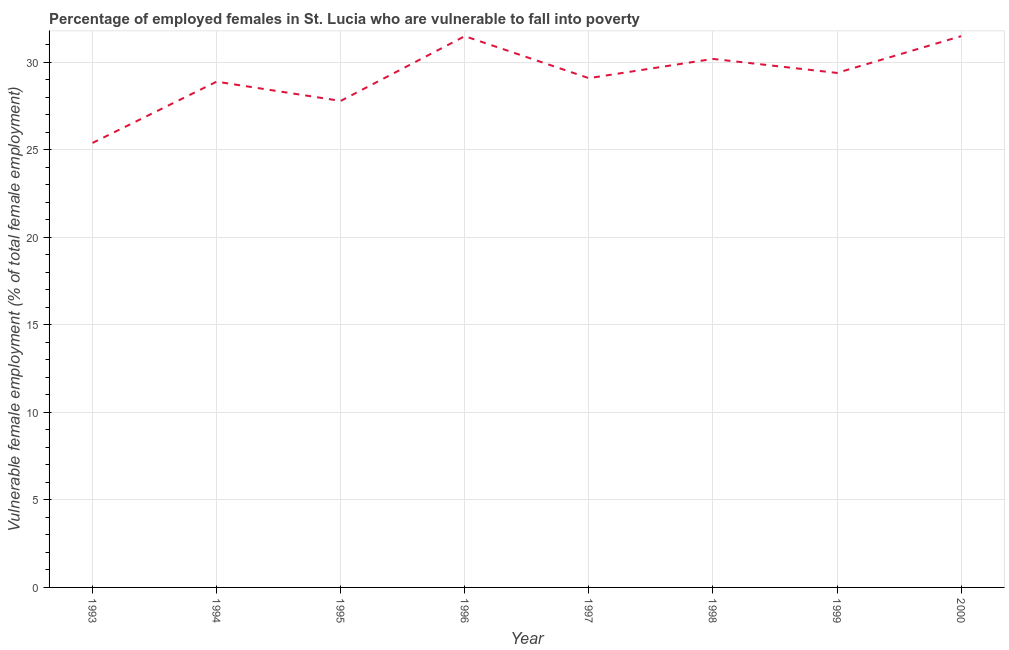What is the percentage of employed females who are vulnerable to fall into poverty in 1998?
Give a very brief answer. 30.2. Across all years, what is the maximum percentage of employed females who are vulnerable to fall into poverty?
Make the answer very short. 31.5. Across all years, what is the minimum percentage of employed females who are vulnerable to fall into poverty?
Keep it short and to the point. 25.4. In which year was the percentage of employed females who are vulnerable to fall into poverty maximum?
Ensure brevity in your answer.  1996. What is the sum of the percentage of employed females who are vulnerable to fall into poverty?
Your response must be concise. 233.8. What is the average percentage of employed females who are vulnerable to fall into poverty per year?
Offer a terse response. 29.22. What is the median percentage of employed females who are vulnerable to fall into poverty?
Your answer should be compact. 29.25. In how many years, is the percentage of employed females who are vulnerable to fall into poverty greater than 4 %?
Your response must be concise. 8. What is the ratio of the percentage of employed females who are vulnerable to fall into poverty in 1993 to that in 2000?
Offer a very short reply. 0.81. What is the difference between the highest and the second highest percentage of employed females who are vulnerable to fall into poverty?
Your answer should be very brief. 0. Is the sum of the percentage of employed females who are vulnerable to fall into poverty in 1997 and 1999 greater than the maximum percentage of employed females who are vulnerable to fall into poverty across all years?
Ensure brevity in your answer.  Yes. What is the difference between the highest and the lowest percentage of employed females who are vulnerable to fall into poverty?
Ensure brevity in your answer.  6.1. How many lines are there?
Make the answer very short. 1. How many years are there in the graph?
Offer a very short reply. 8. What is the difference between two consecutive major ticks on the Y-axis?
Make the answer very short. 5. Are the values on the major ticks of Y-axis written in scientific E-notation?
Your answer should be compact. No. What is the title of the graph?
Offer a very short reply. Percentage of employed females in St. Lucia who are vulnerable to fall into poverty. What is the label or title of the Y-axis?
Your response must be concise. Vulnerable female employment (% of total female employment). What is the Vulnerable female employment (% of total female employment) of 1993?
Keep it short and to the point. 25.4. What is the Vulnerable female employment (% of total female employment) in 1994?
Your answer should be compact. 28.9. What is the Vulnerable female employment (% of total female employment) of 1995?
Make the answer very short. 27.8. What is the Vulnerable female employment (% of total female employment) in 1996?
Make the answer very short. 31.5. What is the Vulnerable female employment (% of total female employment) of 1997?
Offer a very short reply. 29.1. What is the Vulnerable female employment (% of total female employment) in 1998?
Provide a succinct answer. 30.2. What is the Vulnerable female employment (% of total female employment) in 1999?
Give a very brief answer. 29.4. What is the Vulnerable female employment (% of total female employment) of 2000?
Give a very brief answer. 31.5. What is the difference between the Vulnerable female employment (% of total female employment) in 1993 and 1995?
Ensure brevity in your answer.  -2.4. What is the difference between the Vulnerable female employment (% of total female employment) in 1993 and 1996?
Give a very brief answer. -6.1. What is the difference between the Vulnerable female employment (% of total female employment) in 1993 and 1997?
Give a very brief answer. -3.7. What is the difference between the Vulnerable female employment (% of total female employment) in 1993 and 2000?
Keep it short and to the point. -6.1. What is the difference between the Vulnerable female employment (% of total female employment) in 1994 and 1996?
Keep it short and to the point. -2.6. What is the difference between the Vulnerable female employment (% of total female employment) in 1994 and 1997?
Offer a terse response. -0.2. What is the difference between the Vulnerable female employment (% of total female employment) in 1994 and 1998?
Your answer should be very brief. -1.3. What is the difference between the Vulnerable female employment (% of total female employment) in 1995 and 1997?
Offer a terse response. -1.3. What is the difference between the Vulnerable female employment (% of total female employment) in 1995 and 1999?
Offer a terse response. -1.6. What is the difference between the Vulnerable female employment (% of total female employment) in 1995 and 2000?
Your answer should be very brief. -3.7. What is the difference between the Vulnerable female employment (% of total female employment) in 1997 and 1999?
Offer a terse response. -0.3. What is the difference between the Vulnerable female employment (% of total female employment) in 1998 and 1999?
Offer a terse response. 0.8. What is the difference between the Vulnerable female employment (% of total female employment) in 1999 and 2000?
Your answer should be very brief. -2.1. What is the ratio of the Vulnerable female employment (% of total female employment) in 1993 to that in 1994?
Provide a succinct answer. 0.88. What is the ratio of the Vulnerable female employment (% of total female employment) in 1993 to that in 1995?
Give a very brief answer. 0.91. What is the ratio of the Vulnerable female employment (% of total female employment) in 1993 to that in 1996?
Your response must be concise. 0.81. What is the ratio of the Vulnerable female employment (% of total female employment) in 1993 to that in 1997?
Your response must be concise. 0.87. What is the ratio of the Vulnerable female employment (% of total female employment) in 1993 to that in 1998?
Your answer should be very brief. 0.84. What is the ratio of the Vulnerable female employment (% of total female employment) in 1993 to that in 1999?
Offer a terse response. 0.86. What is the ratio of the Vulnerable female employment (% of total female employment) in 1993 to that in 2000?
Offer a very short reply. 0.81. What is the ratio of the Vulnerable female employment (% of total female employment) in 1994 to that in 1996?
Ensure brevity in your answer.  0.92. What is the ratio of the Vulnerable female employment (% of total female employment) in 1994 to that in 1999?
Offer a terse response. 0.98. What is the ratio of the Vulnerable female employment (% of total female employment) in 1994 to that in 2000?
Offer a terse response. 0.92. What is the ratio of the Vulnerable female employment (% of total female employment) in 1995 to that in 1996?
Make the answer very short. 0.88. What is the ratio of the Vulnerable female employment (% of total female employment) in 1995 to that in 1997?
Your answer should be very brief. 0.95. What is the ratio of the Vulnerable female employment (% of total female employment) in 1995 to that in 1998?
Your answer should be very brief. 0.92. What is the ratio of the Vulnerable female employment (% of total female employment) in 1995 to that in 1999?
Give a very brief answer. 0.95. What is the ratio of the Vulnerable female employment (% of total female employment) in 1995 to that in 2000?
Your response must be concise. 0.88. What is the ratio of the Vulnerable female employment (% of total female employment) in 1996 to that in 1997?
Your response must be concise. 1.08. What is the ratio of the Vulnerable female employment (% of total female employment) in 1996 to that in 1998?
Your answer should be very brief. 1.04. What is the ratio of the Vulnerable female employment (% of total female employment) in 1996 to that in 1999?
Provide a succinct answer. 1.07. What is the ratio of the Vulnerable female employment (% of total female employment) in 1997 to that in 2000?
Ensure brevity in your answer.  0.92. What is the ratio of the Vulnerable female employment (% of total female employment) in 1998 to that in 1999?
Provide a succinct answer. 1.03. What is the ratio of the Vulnerable female employment (% of total female employment) in 1999 to that in 2000?
Offer a very short reply. 0.93. 